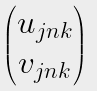Convert formula to latex. <formula><loc_0><loc_0><loc_500><loc_500>\begin{pmatrix} u _ { j n { k } } \\ v _ { j n { k } } \end{pmatrix}</formula> 